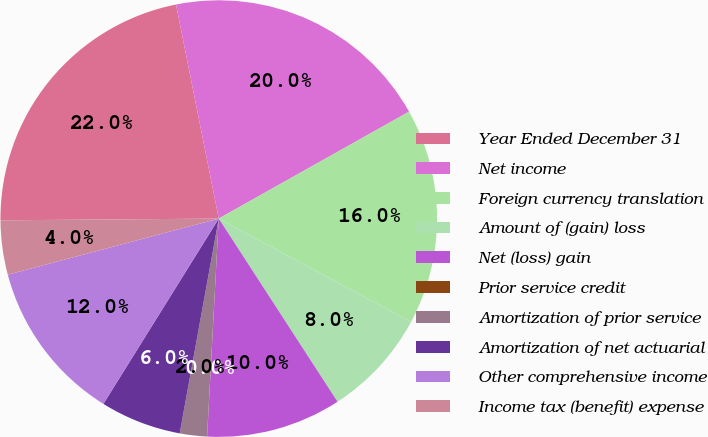Convert chart. <chart><loc_0><loc_0><loc_500><loc_500><pie_chart><fcel>Year Ended December 31<fcel>Net income<fcel>Foreign currency translation<fcel>Amount of (gain) loss<fcel>Net (loss) gain<fcel>Prior service credit<fcel>Amortization of prior service<fcel>Amortization of net actuarial<fcel>Other comprehensive income<fcel>Income tax (benefit) expense<nl><fcel>21.99%<fcel>19.99%<fcel>15.99%<fcel>8.0%<fcel>10.0%<fcel>0.01%<fcel>2.01%<fcel>6.0%<fcel>12.0%<fcel>4.01%<nl></chart> 